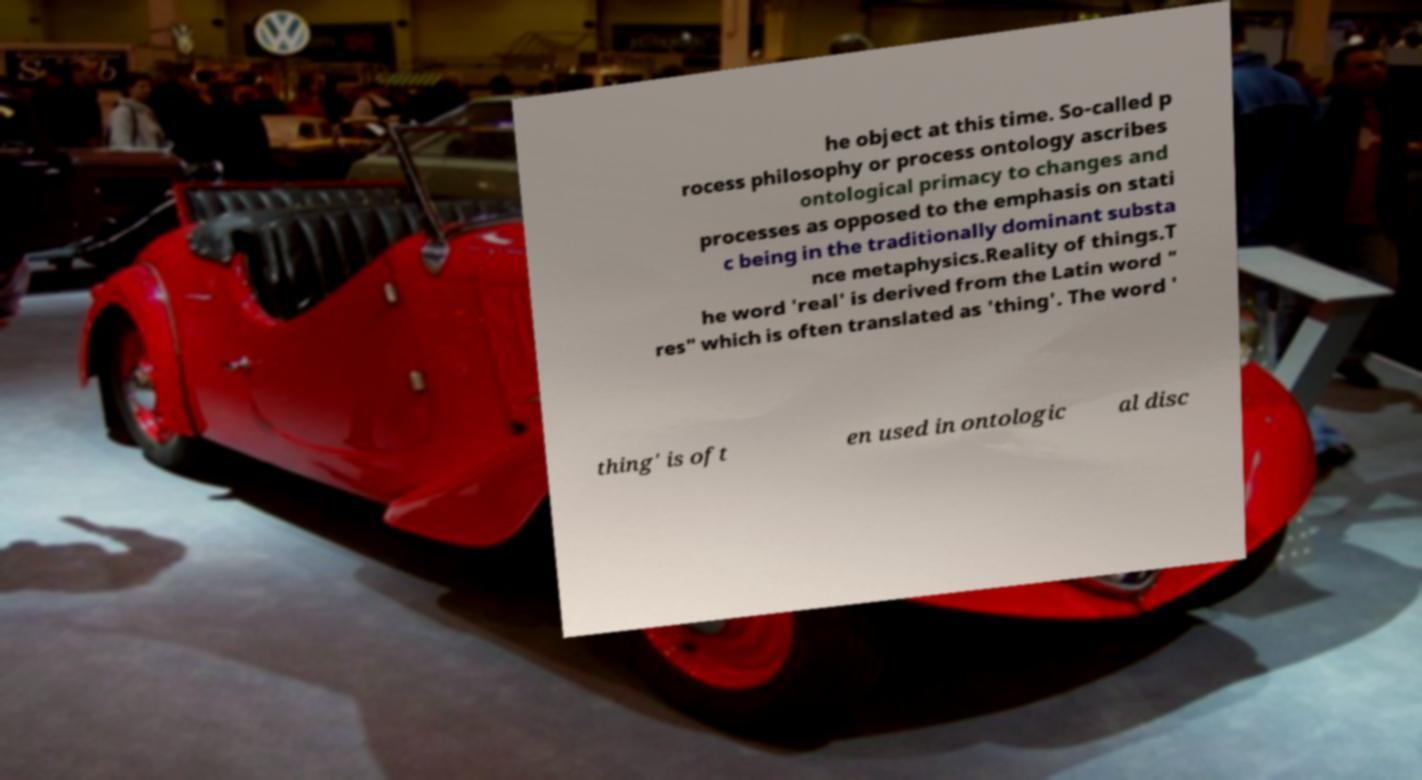What messages or text are displayed in this image? I need them in a readable, typed format. he object at this time. So-called p rocess philosophy or process ontology ascribes ontological primacy to changes and processes as opposed to the emphasis on stati c being in the traditionally dominant substa nce metaphysics.Reality of things.T he word 'real' is derived from the Latin word " res" which is often translated as 'thing'. The word ' thing' is oft en used in ontologic al disc 